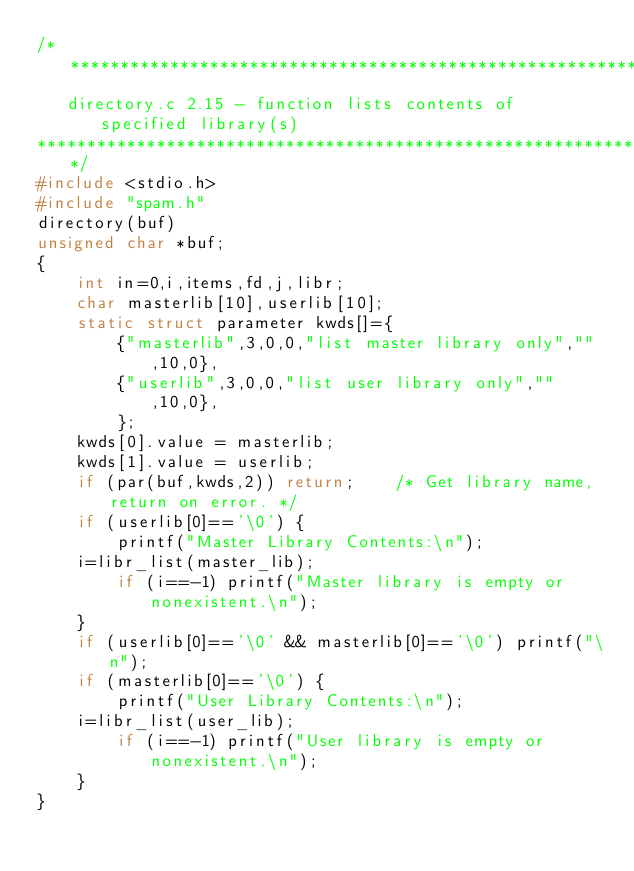<code> <loc_0><loc_0><loc_500><loc_500><_C_>/*************************************************************************
   directory.c 2.15 - function lists contents of specified library(s)
*************************************************************************/
#include <stdio.h>
#include "spam.h"
directory(buf)
unsigned char *buf;
{
    int in=0,i,items,fd,j,libr;
    char masterlib[10],userlib[10];
    static struct parameter kwds[]={
        {"masterlib",3,0,0,"list master library only","",10,0},
        {"userlib",3,0,0,"list user library only","",10,0},
        };
    kwds[0].value = masterlib;
    kwds[1].value = userlib;
    if (par(buf,kwds,2)) return;	/* Get library name, return on error. */
    if (userlib[0]=='\0') {
        printf("Master Library Contents:\n");
	i=libr_list(master_lib);
        if (i==-1) printf("Master library is empty or nonexistent.\n");
    }
    if (userlib[0]=='\0' && masterlib[0]=='\0') printf("\n");
    if (masterlib[0]=='\0') {
        printf("User Library Contents:\n");
	i=libr_list(user_lib);
        if (i==-1) printf("User library is empty or nonexistent.\n");
    }
}
</code> 